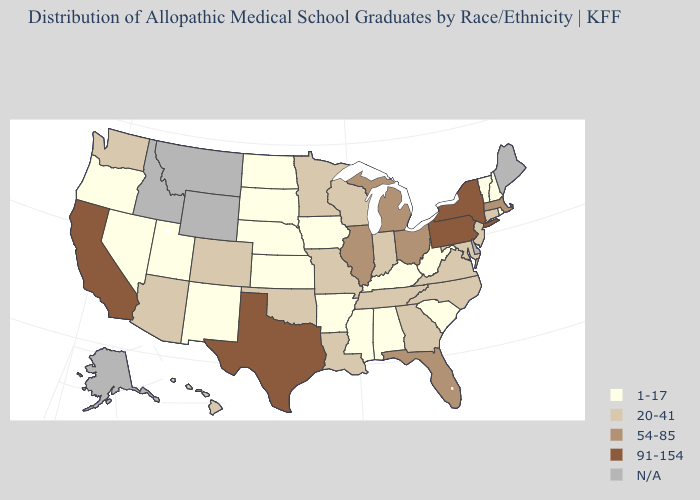Does Pennsylvania have the highest value in the USA?
Write a very short answer. Yes. Name the states that have a value in the range 20-41?
Answer briefly. Arizona, Colorado, Connecticut, Georgia, Hawaii, Indiana, Louisiana, Maryland, Minnesota, Missouri, New Jersey, North Carolina, Oklahoma, Tennessee, Virginia, Washington, Wisconsin. Name the states that have a value in the range 54-85?
Give a very brief answer. Florida, Illinois, Massachusetts, Michigan, Ohio. Which states have the highest value in the USA?
Keep it brief. California, New York, Pennsylvania, Texas. How many symbols are there in the legend?
Write a very short answer. 5. Is the legend a continuous bar?
Concise answer only. No. Does the first symbol in the legend represent the smallest category?
Be succinct. Yes. What is the lowest value in the USA?
Answer briefly. 1-17. What is the highest value in the USA?
Be succinct. 91-154. What is the highest value in the USA?
Be succinct. 91-154. Does Alabama have the lowest value in the South?
Short answer required. Yes. What is the value of Wisconsin?
Write a very short answer. 20-41. Among the states that border North Dakota , does South Dakota have the lowest value?
Concise answer only. Yes. Does New York have the highest value in the USA?
Write a very short answer. Yes. 